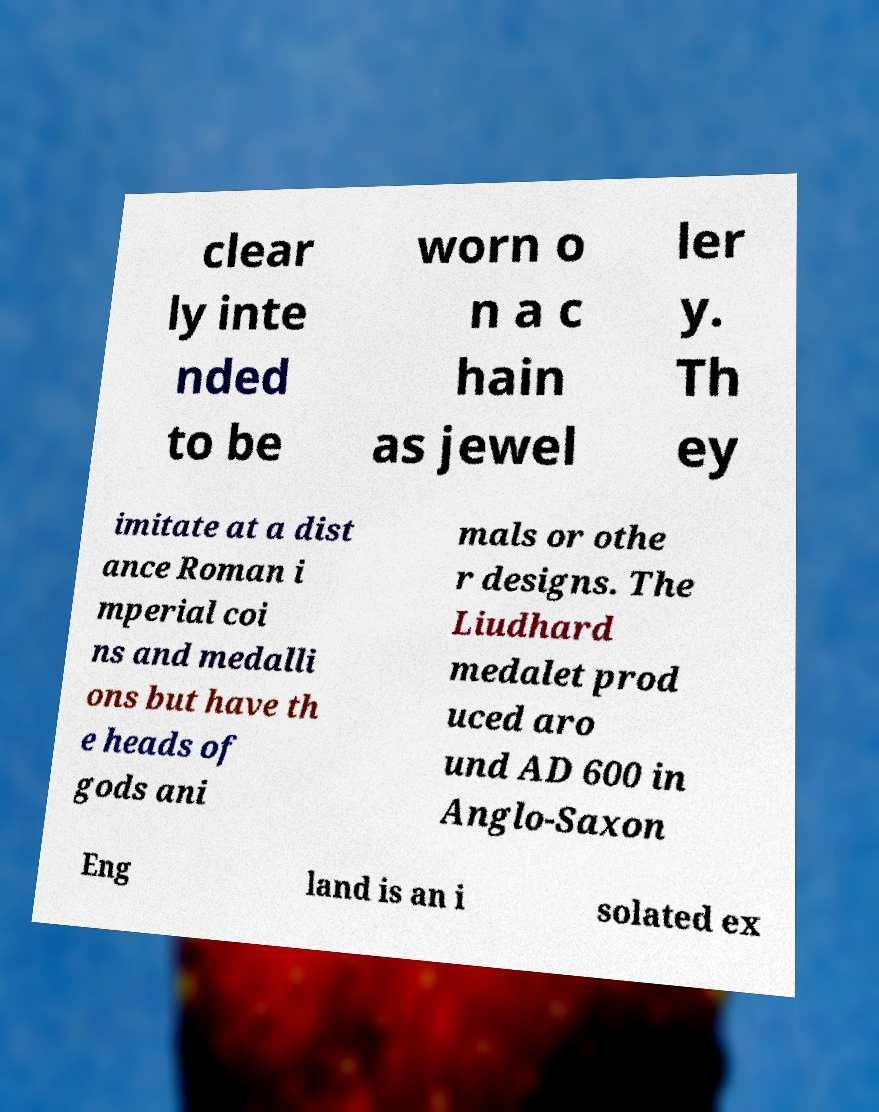Can you accurately transcribe the text from the provided image for me? clear ly inte nded to be worn o n a c hain as jewel ler y. Th ey imitate at a dist ance Roman i mperial coi ns and medalli ons but have th e heads of gods ani mals or othe r designs. The Liudhard medalet prod uced aro und AD 600 in Anglo-Saxon Eng land is an i solated ex 